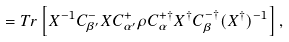<formula> <loc_0><loc_0><loc_500><loc_500>= T r \left [ X ^ { - 1 } C _ { \beta ^ { \prime } } ^ { - } X C _ { \alpha ^ { \prime } } ^ { + } \rho C _ { \alpha } ^ { + \dagger } X ^ { \dagger } C _ { \beta } ^ { - \dagger } ( X ^ { \dagger } ) ^ { - 1 } \right ] ,</formula> 